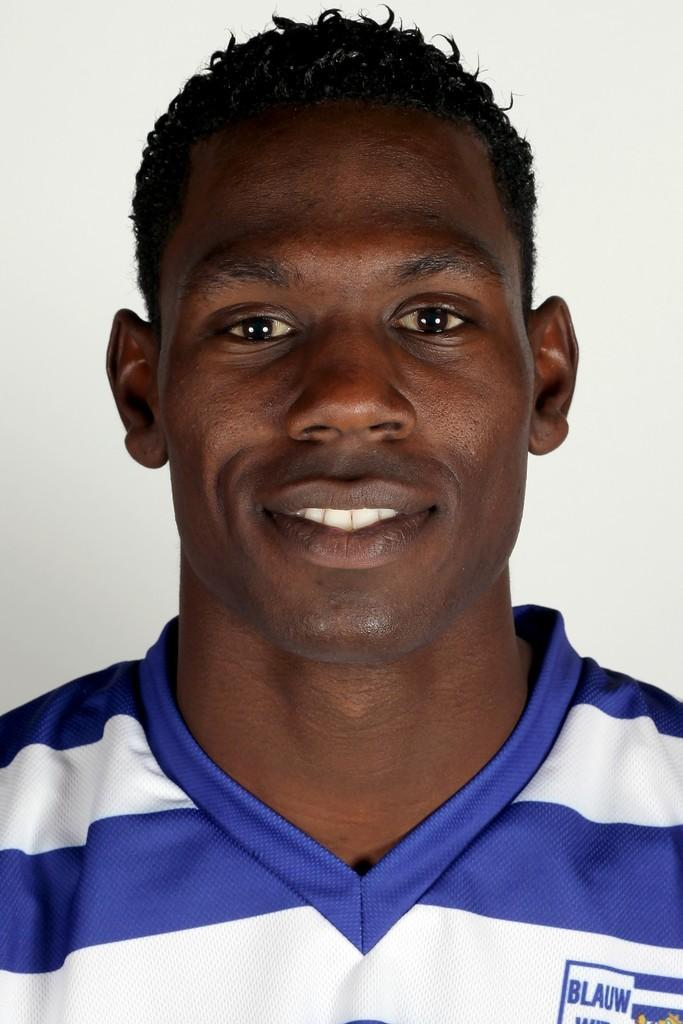<image>
Summarize the visual content of the image. A guy wearing a blue and white shirt with the word BLAUW on it. 